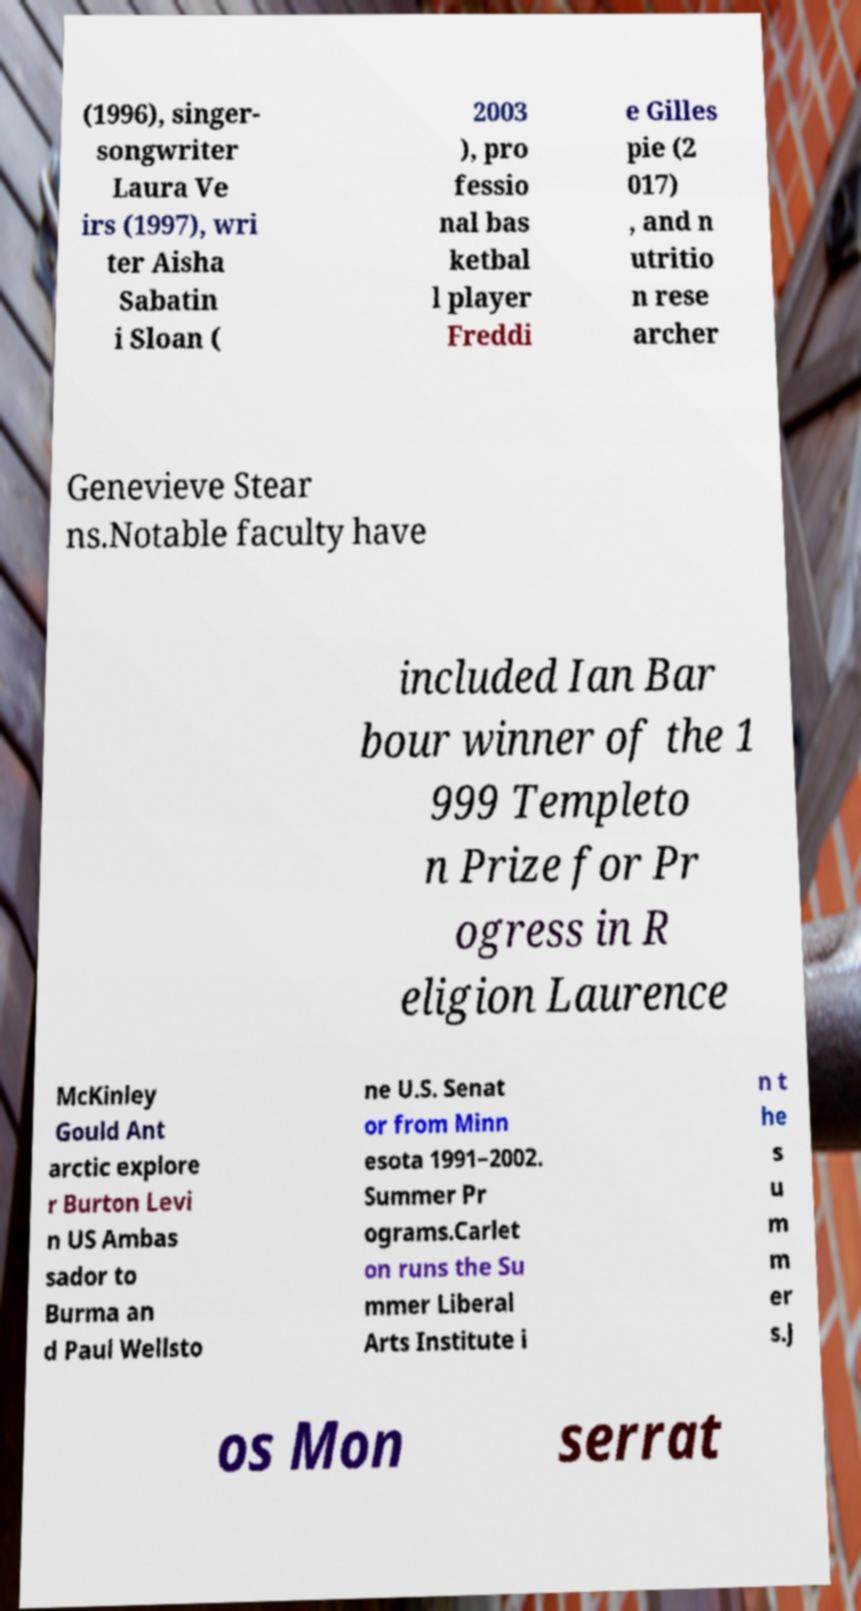What messages or text are displayed in this image? I need them in a readable, typed format. (1996), singer- songwriter Laura Ve irs (1997), wri ter Aisha Sabatin i Sloan ( 2003 ), pro fessio nal bas ketbal l player Freddi e Gilles pie (2 017) , and n utritio n rese archer Genevieve Stear ns.Notable faculty have included Ian Bar bour winner of the 1 999 Templeto n Prize for Pr ogress in R eligion Laurence McKinley Gould Ant arctic explore r Burton Levi n US Ambas sador to Burma an d Paul Wellsto ne U.S. Senat or from Minn esota 1991–2002. Summer Pr ograms.Carlet on runs the Su mmer Liberal Arts Institute i n t he s u m m er s.J os Mon serrat 